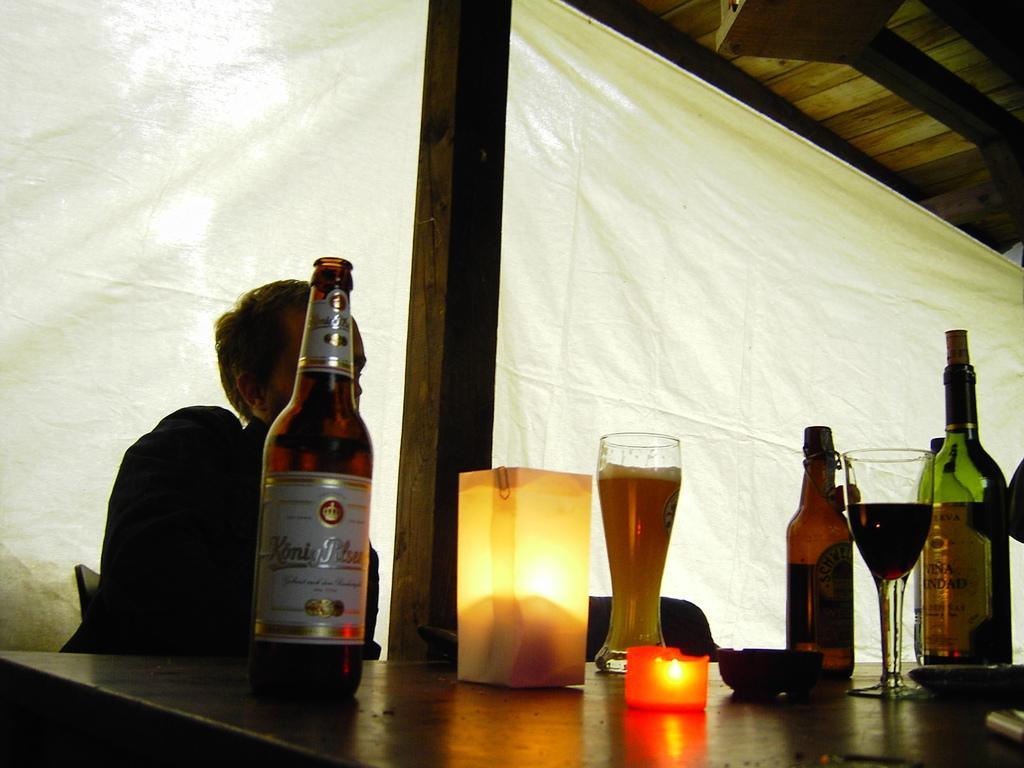What is the person in the image doing? The person is sitting in a chair. What is in front of the person? There is a table in front of the person. What can be seen on the table? The table has wine bottles on it, and there is a glass of wine on the table. What color is the background curtain? The background curtain is white in color. Is there a square-shaped library in the background of the image? No, there is no library or square shape present in the image. 